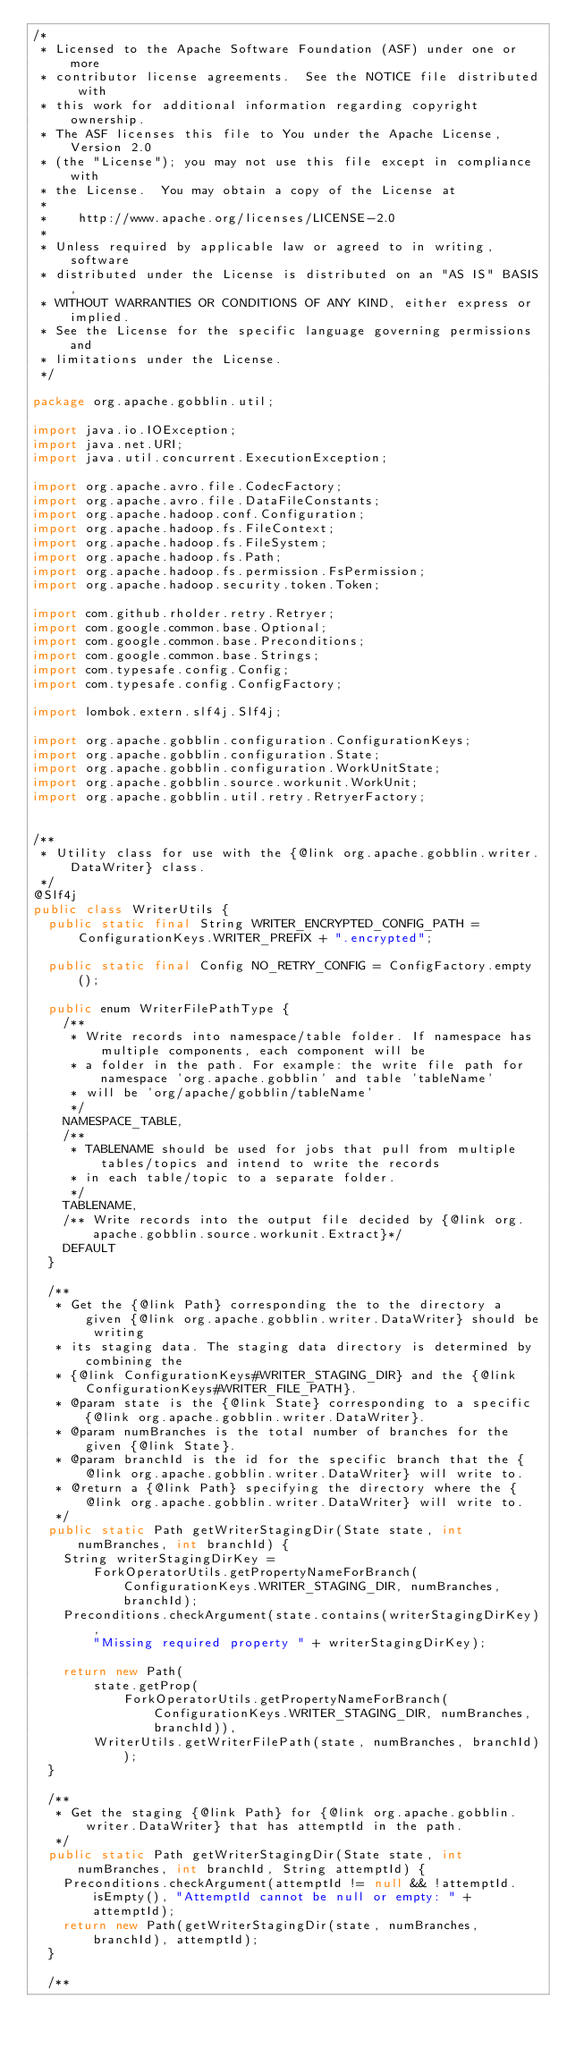<code> <loc_0><loc_0><loc_500><loc_500><_Java_>/*
 * Licensed to the Apache Software Foundation (ASF) under one or more
 * contributor license agreements.  See the NOTICE file distributed with
 * this work for additional information regarding copyright ownership.
 * The ASF licenses this file to You under the Apache License, Version 2.0
 * (the "License"); you may not use this file except in compliance with
 * the License.  You may obtain a copy of the License at
 *
 *    http://www.apache.org/licenses/LICENSE-2.0
 *
 * Unless required by applicable law or agreed to in writing, software
 * distributed under the License is distributed on an "AS IS" BASIS,
 * WITHOUT WARRANTIES OR CONDITIONS OF ANY KIND, either express or implied.
 * See the License for the specific language governing permissions and
 * limitations under the License.
 */

package org.apache.gobblin.util;

import java.io.IOException;
import java.net.URI;
import java.util.concurrent.ExecutionException;

import org.apache.avro.file.CodecFactory;
import org.apache.avro.file.DataFileConstants;
import org.apache.hadoop.conf.Configuration;
import org.apache.hadoop.fs.FileContext;
import org.apache.hadoop.fs.FileSystem;
import org.apache.hadoop.fs.Path;
import org.apache.hadoop.fs.permission.FsPermission;
import org.apache.hadoop.security.token.Token;

import com.github.rholder.retry.Retryer;
import com.google.common.base.Optional;
import com.google.common.base.Preconditions;
import com.google.common.base.Strings;
import com.typesafe.config.Config;
import com.typesafe.config.ConfigFactory;

import lombok.extern.slf4j.Slf4j;

import org.apache.gobblin.configuration.ConfigurationKeys;
import org.apache.gobblin.configuration.State;
import org.apache.gobblin.configuration.WorkUnitState;
import org.apache.gobblin.source.workunit.WorkUnit;
import org.apache.gobblin.util.retry.RetryerFactory;


/**
 * Utility class for use with the {@link org.apache.gobblin.writer.DataWriter} class.
 */
@Slf4j
public class WriterUtils {
  public static final String WRITER_ENCRYPTED_CONFIG_PATH = ConfigurationKeys.WRITER_PREFIX + ".encrypted";

  public static final Config NO_RETRY_CONFIG = ConfigFactory.empty();

  public enum WriterFilePathType {
    /**
     * Write records into namespace/table folder. If namespace has multiple components, each component will be
     * a folder in the path. For example: the write file path for namespace 'org.apache.gobblin' and table 'tableName'
     * will be 'org/apache/gobblin/tableName'
     */
    NAMESPACE_TABLE,
    /**
     * TABLENAME should be used for jobs that pull from multiple tables/topics and intend to write the records
     * in each table/topic to a separate folder.
     */
    TABLENAME,
    /** Write records into the output file decided by {@link org.apache.gobblin.source.workunit.Extract}*/
    DEFAULT
  }

  /**
   * Get the {@link Path} corresponding the to the directory a given {@link org.apache.gobblin.writer.DataWriter} should be writing
   * its staging data. The staging data directory is determined by combining the
   * {@link ConfigurationKeys#WRITER_STAGING_DIR} and the {@link ConfigurationKeys#WRITER_FILE_PATH}.
   * @param state is the {@link State} corresponding to a specific {@link org.apache.gobblin.writer.DataWriter}.
   * @param numBranches is the total number of branches for the given {@link State}.
   * @param branchId is the id for the specific branch that the {@link org.apache.gobblin.writer.DataWriter} will write to.
   * @return a {@link Path} specifying the directory where the {@link org.apache.gobblin.writer.DataWriter} will write to.
   */
  public static Path getWriterStagingDir(State state, int numBranches, int branchId) {
    String writerStagingDirKey =
        ForkOperatorUtils.getPropertyNameForBranch(ConfigurationKeys.WRITER_STAGING_DIR, numBranches, branchId);
    Preconditions.checkArgument(state.contains(writerStagingDirKey),
        "Missing required property " + writerStagingDirKey);

    return new Path(
        state.getProp(
            ForkOperatorUtils.getPropertyNameForBranch(ConfigurationKeys.WRITER_STAGING_DIR, numBranches, branchId)),
        WriterUtils.getWriterFilePath(state, numBranches, branchId));
  }

  /**
   * Get the staging {@link Path} for {@link org.apache.gobblin.writer.DataWriter} that has attemptId in the path.
   */
  public static Path getWriterStagingDir(State state, int numBranches, int branchId, String attemptId) {
    Preconditions.checkArgument(attemptId != null && !attemptId.isEmpty(), "AttemptId cannot be null or empty: " + attemptId);
    return new Path(getWriterStagingDir(state, numBranches, branchId), attemptId);
  }

  /**</code> 